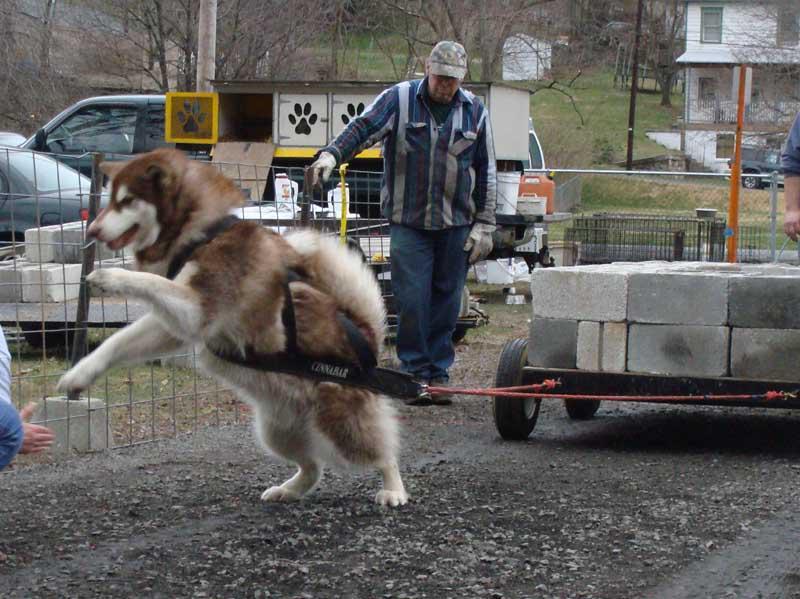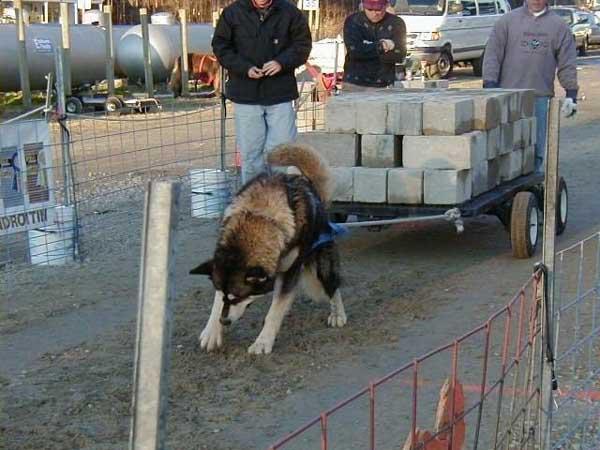The first image is the image on the left, the second image is the image on the right. Evaluate the accuracy of this statement regarding the images: "One image shows a leftward-turned dog in a harness leaning forward in profile as it strains to pull something that is out of sight, and the other image shows a dog standing on all fours with its head raised and mouth open.". Is it true? Answer yes or no. No. The first image is the image on the left, the second image is the image on the right. Assess this claim about the two images: "A dog is pulling a cart using only its hind legs in one of the pictures.". Correct or not? Answer yes or no. Yes. 